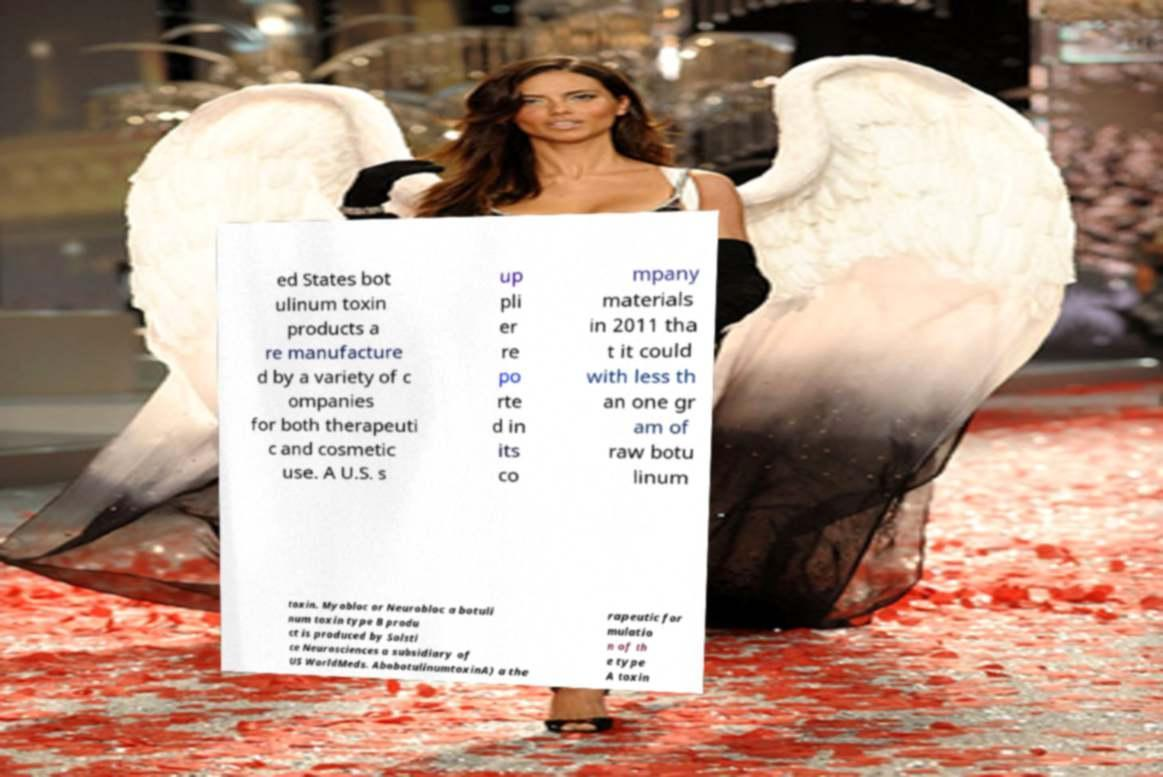Please identify and transcribe the text found in this image. ed States bot ulinum toxin products a re manufacture d by a variety of c ompanies for both therapeuti c and cosmetic use. A U.S. s up pli er re po rte d in its co mpany materials in 2011 tha t it could with less th an one gr am of raw botu linum toxin. Myobloc or Neurobloc a botuli num toxin type B produ ct is produced by Solsti ce Neurosciences a subsidiary of US WorldMeds. AbobotulinumtoxinA) a the rapeutic for mulatio n of th e type A toxin 